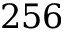<formula> <loc_0><loc_0><loc_500><loc_500>2 5 6</formula> 